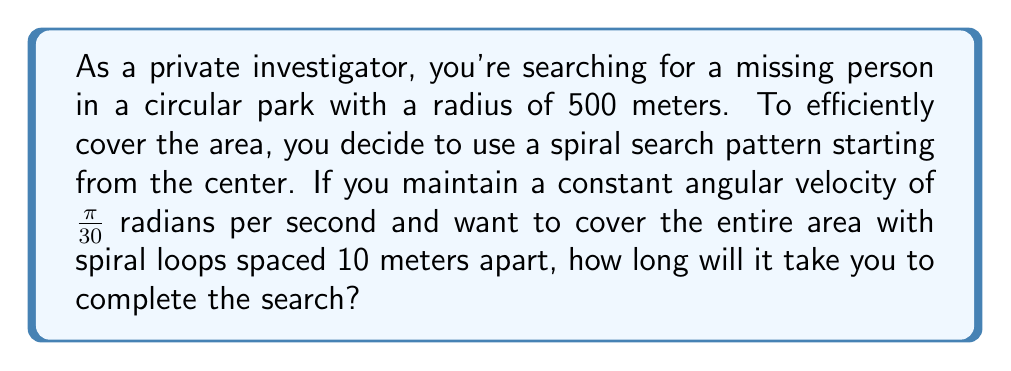Teach me how to tackle this problem. To solve this problem, we need to use polar coordinates and the concept of an Archimedean spiral. Let's break it down step-by-step:

1) The equation of an Archimedean spiral in polar coordinates is:
   $r = a\theta$
   where $r$ is the radius, $\theta$ is the angle in radians, and $a$ is the distance between successive turnings.

2) In our case, $a = \frac{10}{2\pi} \approx 1.59$ meters per radian, as we want the spiral loops to be 10 meters apart.

3) To reach the edge of the park (r = 500 m), we need to find the total angle $\theta$:
   $500 = 1.59\theta$
   $\theta = \frac{500}{1.59} \approx 314.47$ radians

4) Given the angular velocity $\omega = \frac{\pi}{30}$ rad/s, we can find the time using:
   $t = \frac{\theta}{\omega} = \frac{314.47}{\frac{\pi}{30}} \approx 3000$ seconds

5) To convert this to minutes:
   $3000 \text{ seconds} \times \frac{1 \text{ minute}}{60 \text{ seconds}} = 50 \text{ minutes}$

Therefore, it will take approximately 50 minutes to complete the search.

[asy]
import graph;
size(200);
real r(real t) {return 0.05*t;}
draw(polargraph(r,0,20pi,operator ..),Arrow);
draw(circle((0,0),10),dashed);
label("Start",(0,0),NW);
label("End",(10,0),E);
[/asy]
Answer: It will take approximately 50 minutes to complete the search. 